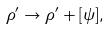<formula> <loc_0><loc_0><loc_500><loc_500>\rho ^ { \prime } \rightarrow \rho ^ { \prime } + [ \psi ] ,</formula> 